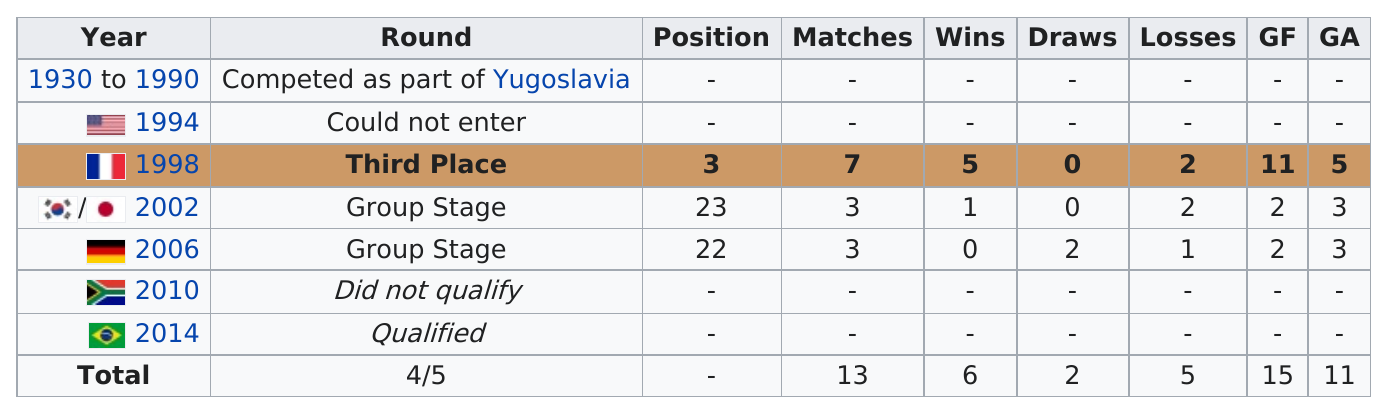List a handful of essential elements in this visual. Croatia has qualified for the FIFA World Cup three times consecutively. Croatia played 7 matches in the 1998 World Cup. In 1998, there were more losses than in 2006. In 2002, Croatia had two losses, and in another year that has not been specified, they also lost. The year that Croatia lost twice in is unknown. In the year 2006, Croatia was defeated by their opponents and was scored on three times. 